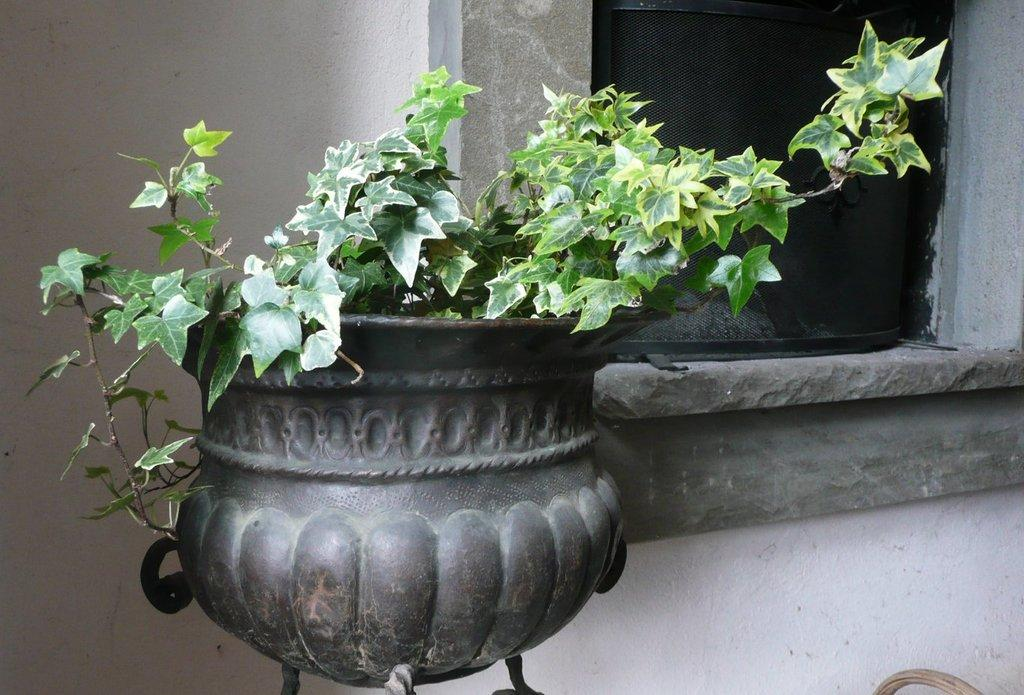What type of plant is in the image? There is a plant in a pot in the image. What can be seen in the background of the image? There is a wall and a window in the background of the image. How many bears are sitting on the tree in the image? There is no tree or bears present in the image. 